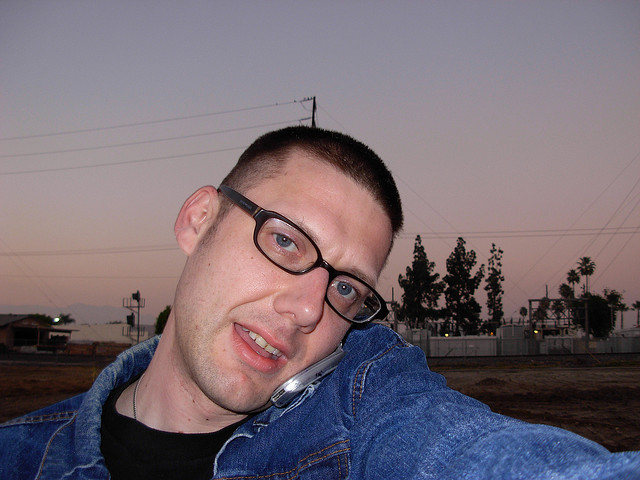<image>Is the man hungry? I am not sure if the man is hungry. Is the man hungry? I don't know if the man is hungry. It is not clear from the given answers. 